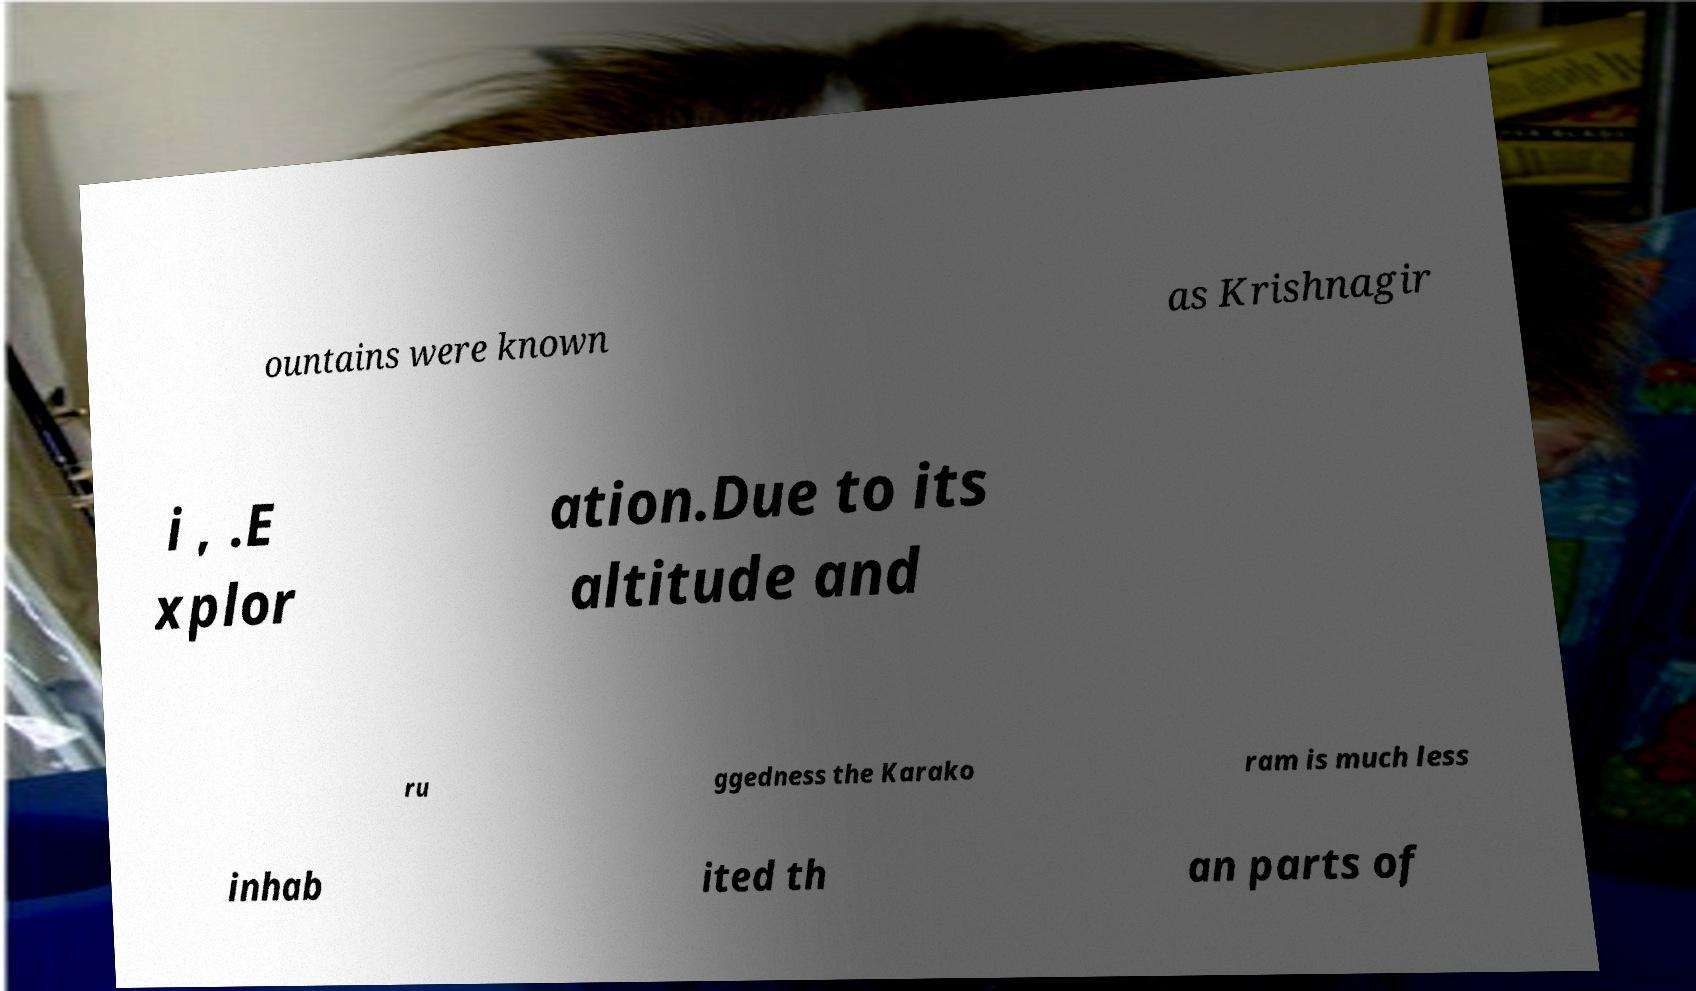Could you extract and type out the text from this image? ountains were known as Krishnagir i , .E xplor ation.Due to its altitude and ru ggedness the Karako ram is much less inhab ited th an parts of 